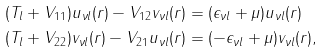Convert formula to latex. <formula><loc_0><loc_0><loc_500><loc_500>( T _ { l } + V _ { 1 1 } ) u _ { \nu l } ( { r } ) - V _ { 1 2 } v _ { \nu l } ( { r } ) & = ( \epsilon _ { \nu l } + \mu ) u _ { \nu l } ( { r } ) \\ ( T _ { l } + V _ { 2 2 } ) v _ { \nu l } ( { r } ) - V _ { 2 1 } u _ { \nu l } ( { r } ) & = ( - \epsilon _ { \nu l } + \mu ) v _ { \nu l } ( { r } ) ,</formula> 